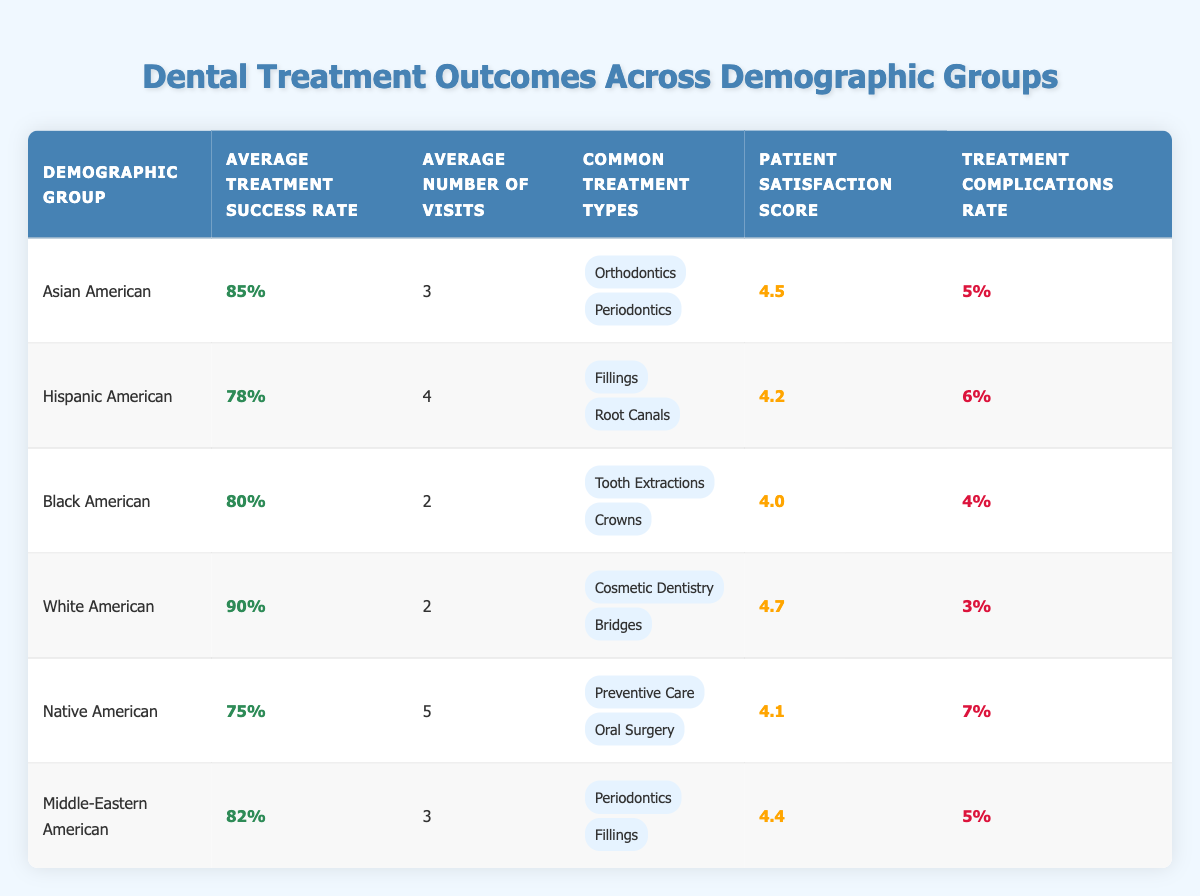What is the average treatment success rate for White Americans? The table shows that the average treatment success rate for White Americans is listed as 90%.
Answer: 90% How many visits do Hispanic Americans typically require for dental treatment? According to the table, Hispanic Americans average 4 visits for dental treatment.
Answer: 4 Which demographic group has the highest patient satisfaction score? From the table, White Americans have the highest patient satisfaction score of 4.7.
Answer: White American What is the treatment complications rate for Native Americans? The table indicates that the treatment complications rate for Native Americans is 7%.
Answer: 7% What is the average number of visits for Black Americans compared to Asian Americans? Black Americans average 2 visits, while Asian Americans average 3 visits. Therefore, Black Americans have 1 fewer visit than Asian Americans.
Answer: 1 less visit Calculate the average treatment success rate across all demographic groups. To find the average treatment success rate, add the rates: (85 + 78 + 80 + 90 + 75 + 82) = 490, then divide by the number of groups (6): 490 / 6 ≈ 81.67%.
Answer: Approximately 81.67% Does any demographic group have an average treatment success rate below 80%? Yes, the Native Americans have an average treatment success rate of 75%, which is below 80%.
Answer: Yes Which group has the second highest treatment complications rate? The treatment complications rates are: Asian American (5%), Hispanic American (6%), Black American (4%), White American (3%), Native American (7%), and Middle-Eastern American (5%). Native Americans have the highest at 7%, and Hispanic Americans have the second highest at 6%.
Answer: Hispanic American Is the average number of visits for Middle-Eastern Americans the same as for Asian Americans? Middle-Eastern Americans average 3 visits, whereas Asian Americans also average 3 visits, indicating they are the same.
Answer: Yes If we compare patient satisfaction scores, which group has the lowest score? The table shows the patient satisfaction scores: Asian American (4.5), Hispanic American (4.2), Black American (4.0), White American (4.7), Native American (4.1), and Middle-Eastern American (4.4). Black Americans have the lowest score at 4.0.
Answer: Black American 